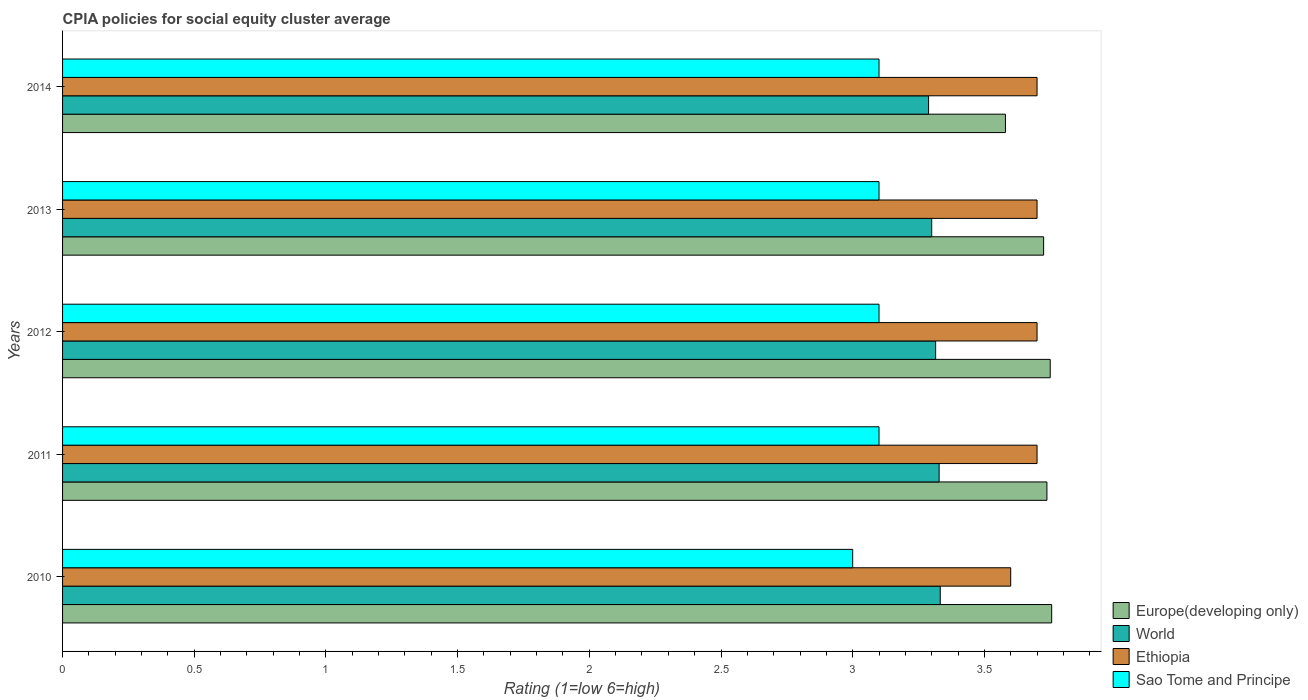How many different coloured bars are there?
Provide a succinct answer. 4. How many groups of bars are there?
Your answer should be compact. 5. Are the number of bars on each tick of the Y-axis equal?
Make the answer very short. Yes. How many bars are there on the 1st tick from the top?
Offer a very short reply. 4. What is the label of the 1st group of bars from the top?
Offer a terse response. 2014. Across all years, what is the maximum CPIA rating in Ethiopia?
Provide a short and direct response. 3.7. Across all years, what is the minimum CPIA rating in Europe(developing only)?
Your response must be concise. 3.58. In which year was the CPIA rating in Ethiopia maximum?
Offer a terse response. 2011. What is the total CPIA rating in Europe(developing only) in the graph?
Give a very brief answer. 18.55. What is the difference between the CPIA rating in Europe(developing only) in 2010 and that in 2012?
Give a very brief answer. 0.01. What is the difference between the CPIA rating in Sao Tome and Principe in 2010 and the CPIA rating in Europe(developing only) in 2011?
Ensure brevity in your answer.  -0.74. What is the average CPIA rating in World per year?
Your answer should be compact. 3.31. In the year 2014, what is the difference between the CPIA rating in Ethiopia and CPIA rating in World?
Provide a succinct answer. 0.41. What is the ratio of the CPIA rating in Europe(developing only) in 2012 to that in 2013?
Provide a short and direct response. 1.01. Is the difference between the CPIA rating in Ethiopia in 2013 and 2014 greater than the difference between the CPIA rating in World in 2013 and 2014?
Your answer should be very brief. No. What is the difference between the highest and the second highest CPIA rating in Europe(developing only)?
Offer a terse response. 0.01. What is the difference between the highest and the lowest CPIA rating in Ethiopia?
Offer a very short reply. 0.1. In how many years, is the CPIA rating in Europe(developing only) greater than the average CPIA rating in Europe(developing only) taken over all years?
Ensure brevity in your answer.  4. Is the sum of the CPIA rating in World in 2011 and 2014 greater than the maximum CPIA rating in Europe(developing only) across all years?
Make the answer very short. Yes. What does the 1st bar from the bottom in 2010 represents?
Offer a very short reply. Europe(developing only). Is it the case that in every year, the sum of the CPIA rating in World and CPIA rating in Ethiopia is greater than the CPIA rating in Sao Tome and Principe?
Make the answer very short. Yes. How many bars are there?
Keep it short and to the point. 20. Are all the bars in the graph horizontal?
Make the answer very short. Yes. How many years are there in the graph?
Give a very brief answer. 5. Where does the legend appear in the graph?
Offer a very short reply. Bottom right. How are the legend labels stacked?
Your response must be concise. Vertical. What is the title of the graph?
Make the answer very short. CPIA policies for social equity cluster average. Does "Yemen, Rep." appear as one of the legend labels in the graph?
Keep it short and to the point. No. What is the label or title of the X-axis?
Offer a very short reply. Rating (1=low 6=high). What is the Rating (1=low 6=high) of Europe(developing only) in 2010?
Ensure brevity in your answer.  3.76. What is the Rating (1=low 6=high) in World in 2010?
Your answer should be very brief. 3.33. What is the Rating (1=low 6=high) in Ethiopia in 2010?
Keep it short and to the point. 3.6. What is the Rating (1=low 6=high) of Europe(developing only) in 2011?
Offer a terse response. 3.74. What is the Rating (1=low 6=high) of World in 2011?
Offer a very short reply. 3.33. What is the Rating (1=low 6=high) of Europe(developing only) in 2012?
Your answer should be very brief. 3.75. What is the Rating (1=low 6=high) of World in 2012?
Provide a succinct answer. 3.31. What is the Rating (1=low 6=high) in Europe(developing only) in 2013?
Give a very brief answer. 3.73. What is the Rating (1=low 6=high) in World in 2013?
Provide a succinct answer. 3.3. What is the Rating (1=low 6=high) of Ethiopia in 2013?
Your response must be concise. 3.7. What is the Rating (1=low 6=high) in Sao Tome and Principe in 2013?
Provide a short and direct response. 3.1. What is the Rating (1=low 6=high) in Europe(developing only) in 2014?
Give a very brief answer. 3.58. What is the Rating (1=low 6=high) of World in 2014?
Offer a very short reply. 3.29. What is the Rating (1=low 6=high) of Ethiopia in 2014?
Offer a terse response. 3.7. What is the Rating (1=low 6=high) in Sao Tome and Principe in 2014?
Offer a terse response. 3.1. Across all years, what is the maximum Rating (1=low 6=high) in Europe(developing only)?
Your answer should be compact. 3.76. Across all years, what is the maximum Rating (1=low 6=high) in World?
Provide a short and direct response. 3.33. Across all years, what is the minimum Rating (1=low 6=high) of Europe(developing only)?
Give a very brief answer. 3.58. Across all years, what is the minimum Rating (1=low 6=high) of World?
Provide a short and direct response. 3.29. Across all years, what is the minimum Rating (1=low 6=high) of Ethiopia?
Make the answer very short. 3.6. What is the total Rating (1=low 6=high) of Europe(developing only) in the graph?
Offer a terse response. 18.55. What is the total Rating (1=low 6=high) in World in the graph?
Your answer should be very brief. 16.56. What is the total Rating (1=low 6=high) in Ethiopia in the graph?
Offer a terse response. 18.4. What is the difference between the Rating (1=low 6=high) of Europe(developing only) in 2010 and that in 2011?
Make the answer very short. 0.02. What is the difference between the Rating (1=low 6=high) of World in 2010 and that in 2011?
Give a very brief answer. 0. What is the difference between the Rating (1=low 6=high) of Ethiopia in 2010 and that in 2011?
Provide a short and direct response. -0.1. What is the difference between the Rating (1=low 6=high) in Europe(developing only) in 2010 and that in 2012?
Ensure brevity in your answer.  0.01. What is the difference between the Rating (1=low 6=high) in World in 2010 and that in 2012?
Make the answer very short. 0.02. What is the difference between the Rating (1=low 6=high) in Europe(developing only) in 2010 and that in 2013?
Offer a very short reply. 0.03. What is the difference between the Rating (1=low 6=high) in World in 2010 and that in 2013?
Your answer should be compact. 0.03. What is the difference between the Rating (1=low 6=high) in Ethiopia in 2010 and that in 2013?
Offer a very short reply. -0.1. What is the difference between the Rating (1=low 6=high) in Europe(developing only) in 2010 and that in 2014?
Provide a succinct answer. 0.18. What is the difference between the Rating (1=low 6=high) in World in 2010 and that in 2014?
Provide a short and direct response. 0.04. What is the difference between the Rating (1=low 6=high) in Ethiopia in 2010 and that in 2014?
Provide a succinct answer. -0.1. What is the difference between the Rating (1=low 6=high) in Sao Tome and Principe in 2010 and that in 2014?
Give a very brief answer. -0.1. What is the difference between the Rating (1=low 6=high) in Europe(developing only) in 2011 and that in 2012?
Make the answer very short. -0.01. What is the difference between the Rating (1=low 6=high) of World in 2011 and that in 2012?
Provide a short and direct response. 0.01. What is the difference between the Rating (1=low 6=high) of Ethiopia in 2011 and that in 2012?
Make the answer very short. 0. What is the difference between the Rating (1=low 6=high) of Europe(developing only) in 2011 and that in 2013?
Ensure brevity in your answer.  0.01. What is the difference between the Rating (1=low 6=high) of World in 2011 and that in 2013?
Offer a very short reply. 0.03. What is the difference between the Rating (1=low 6=high) in Europe(developing only) in 2011 and that in 2014?
Your answer should be very brief. 0.16. What is the difference between the Rating (1=low 6=high) in World in 2011 and that in 2014?
Provide a succinct answer. 0.04. What is the difference between the Rating (1=low 6=high) of Ethiopia in 2011 and that in 2014?
Give a very brief answer. 0. What is the difference between the Rating (1=low 6=high) in Europe(developing only) in 2012 and that in 2013?
Provide a succinct answer. 0.03. What is the difference between the Rating (1=low 6=high) of World in 2012 and that in 2013?
Offer a very short reply. 0.01. What is the difference between the Rating (1=low 6=high) of Europe(developing only) in 2012 and that in 2014?
Your response must be concise. 0.17. What is the difference between the Rating (1=low 6=high) in World in 2012 and that in 2014?
Offer a terse response. 0.03. What is the difference between the Rating (1=low 6=high) of Ethiopia in 2012 and that in 2014?
Your answer should be compact. 0. What is the difference between the Rating (1=low 6=high) of Sao Tome and Principe in 2012 and that in 2014?
Give a very brief answer. 0. What is the difference between the Rating (1=low 6=high) of Europe(developing only) in 2013 and that in 2014?
Keep it short and to the point. 0.14. What is the difference between the Rating (1=low 6=high) of World in 2013 and that in 2014?
Your answer should be compact. 0.01. What is the difference between the Rating (1=low 6=high) in Europe(developing only) in 2010 and the Rating (1=low 6=high) in World in 2011?
Ensure brevity in your answer.  0.43. What is the difference between the Rating (1=low 6=high) in Europe(developing only) in 2010 and the Rating (1=low 6=high) in Ethiopia in 2011?
Offer a terse response. 0.06. What is the difference between the Rating (1=low 6=high) in Europe(developing only) in 2010 and the Rating (1=low 6=high) in Sao Tome and Principe in 2011?
Provide a succinct answer. 0.66. What is the difference between the Rating (1=low 6=high) in World in 2010 and the Rating (1=low 6=high) in Ethiopia in 2011?
Make the answer very short. -0.37. What is the difference between the Rating (1=low 6=high) of World in 2010 and the Rating (1=low 6=high) of Sao Tome and Principe in 2011?
Provide a short and direct response. 0.23. What is the difference between the Rating (1=low 6=high) of Europe(developing only) in 2010 and the Rating (1=low 6=high) of World in 2012?
Give a very brief answer. 0.44. What is the difference between the Rating (1=low 6=high) in Europe(developing only) in 2010 and the Rating (1=low 6=high) in Ethiopia in 2012?
Provide a short and direct response. 0.06. What is the difference between the Rating (1=low 6=high) in Europe(developing only) in 2010 and the Rating (1=low 6=high) in Sao Tome and Principe in 2012?
Give a very brief answer. 0.66. What is the difference between the Rating (1=low 6=high) in World in 2010 and the Rating (1=low 6=high) in Ethiopia in 2012?
Ensure brevity in your answer.  -0.37. What is the difference between the Rating (1=low 6=high) in World in 2010 and the Rating (1=low 6=high) in Sao Tome and Principe in 2012?
Your answer should be compact. 0.23. What is the difference between the Rating (1=low 6=high) of Ethiopia in 2010 and the Rating (1=low 6=high) of Sao Tome and Principe in 2012?
Offer a terse response. 0.5. What is the difference between the Rating (1=low 6=high) of Europe(developing only) in 2010 and the Rating (1=low 6=high) of World in 2013?
Ensure brevity in your answer.  0.46. What is the difference between the Rating (1=low 6=high) of Europe(developing only) in 2010 and the Rating (1=low 6=high) of Ethiopia in 2013?
Make the answer very short. 0.06. What is the difference between the Rating (1=low 6=high) of Europe(developing only) in 2010 and the Rating (1=low 6=high) of Sao Tome and Principe in 2013?
Your answer should be compact. 0.66. What is the difference between the Rating (1=low 6=high) of World in 2010 and the Rating (1=low 6=high) of Ethiopia in 2013?
Your answer should be very brief. -0.37. What is the difference between the Rating (1=low 6=high) in World in 2010 and the Rating (1=low 6=high) in Sao Tome and Principe in 2013?
Make the answer very short. 0.23. What is the difference between the Rating (1=low 6=high) of Europe(developing only) in 2010 and the Rating (1=low 6=high) of World in 2014?
Give a very brief answer. 0.47. What is the difference between the Rating (1=low 6=high) in Europe(developing only) in 2010 and the Rating (1=low 6=high) in Ethiopia in 2014?
Give a very brief answer. 0.06. What is the difference between the Rating (1=low 6=high) of Europe(developing only) in 2010 and the Rating (1=low 6=high) of Sao Tome and Principe in 2014?
Your answer should be compact. 0.66. What is the difference between the Rating (1=low 6=high) in World in 2010 and the Rating (1=low 6=high) in Ethiopia in 2014?
Keep it short and to the point. -0.37. What is the difference between the Rating (1=low 6=high) of World in 2010 and the Rating (1=low 6=high) of Sao Tome and Principe in 2014?
Keep it short and to the point. 0.23. What is the difference between the Rating (1=low 6=high) in Ethiopia in 2010 and the Rating (1=low 6=high) in Sao Tome and Principe in 2014?
Your answer should be very brief. 0.5. What is the difference between the Rating (1=low 6=high) in Europe(developing only) in 2011 and the Rating (1=low 6=high) in World in 2012?
Offer a terse response. 0.42. What is the difference between the Rating (1=low 6=high) of Europe(developing only) in 2011 and the Rating (1=low 6=high) of Ethiopia in 2012?
Your response must be concise. 0.04. What is the difference between the Rating (1=low 6=high) of Europe(developing only) in 2011 and the Rating (1=low 6=high) of Sao Tome and Principe in 2012?
Offer a terse response. 0.64. What is the difference between the Rating (1=low 6=high) in World in 2011 and the Rating (1=low 6=high) in Ethiopia in 2012?
Provide a short and direct response. -0.37. What is the difference between the Rating (1=low 6=high) in World in 2011 and the Rating (1=low 6=high) in Sao Tome and Principe in 2012?
Provide a short and direct response. 0.23. What is the difference between the Rating (1=low 6=high) of Ethiopia in 2011 and the Rating (1=low 6=high) of Sao Tome and Principe in 2012?
Your answer should be very brief. 0.6. What is the difference between the Rating (1=low 6=high) of Europe(developing only) in 2011 and the Rating (1=low 6=high) of World in 2013?
Keep it short and to the point. 0.44. What is the difference between the Rating (1=low 6=high) of Europe(developing only) in 2011 and the Rating (1=low 6=high) of Ethiopia in 2013?
Offer a very short reply. 0.04. What is the difference between the Rating (1=low 6=high) of Europe(developing only) in 2011 and the Rating (1=low 6=high) of Sao Tome and Principe in 2013?
Keep it short and to the point. 0.64. What is the difference between the Rating (1=low 6=high) of World in 2011 and the Rating (1=low 6=high) of Ethiopia in 2013?
Ensure brevity in your answer.  -0.37. What is the difference between the Rating (1=low 6=high) of World in 2011 and the Rating (1=low 6=high) of Sao Tome and Principe in 2013?
Your answer should be very brief. 0.23. What is the difference between the Rating (1=low 6=high) of Ethiopia in 2011 and the Rating (1=low 6=high) of Sao Tome and Principe in 2013?
Offer a very short reply. 0.6. What is the difference between the Rating (1=low 6=high) of Europe(developing only) in 2011 and the Rating (1=low 6=high) of World in 2014?
Ensure brevity in your answer.  0.45. What is the difference between the Rating (1=low 6=high) in Europe(developing only) in 2011 and the Rating (1=low 6=high) in Ethiopia in 2014?
Your answer should be very brief. 0.04. What is the difference between the Rating (1=low 6=high) of Europe(developing only) in 2011 and the Rating (1=low 6=high) of Sao Tome and Principe in 2014?
Offer a terse response. 0.64. What is the difference between the Rating (1=low 6=high) of World in 2011 and the Rating (1=low 6=high) of Ethiopia in 2014?
Keep it short and to the point. -0.37. What is the difference between the Rating (1=low 6=high) in World in 2011 and the Rating (1=low 6=high) in Sao Tome and Principe in 2014?
Give a very brief answer. 0.23. What is the difference between the Rating (1=low 6=high) in Europe(developing only) in 2012 and the Rating (1=low 6=high) in World in 2013?
Provide a short and direct response. 0.45. What is the difference between the Rating (1=low 6=high) in Europe(developing only) in 2012 and the Rating (1=low 6=high) in Sao Tome and Principe in 2013?
Your answer should be very brief. 0.65. What is the difference between the Rating (1=low 6=high) of World in 2012 and the Rating (1=low 6=high) of Ethiopia in 2013?
Keep it short and to the point. -0.39. What is the difference between the Rating (1=low 6=high) of World in 2012 and the Rating (1=low 6=high) of Sao Tome and Principe in 2013?
Ensure brevity in your answer.  0.21. What is the difference between the Rating (1=low 6=high) of Europe(developing only) in 2012 and the Rating (1=low 6=high) of World in 2014?
Your answer should be very brief. 0.46. What is the difference between the Rating (1=low 6=high) in Europe(developing only) in 2012 and the Rating (1=low 6=high) in Sao Tome and Principe in 2014?
Your answer should be very brief. 0.65. What is the difference between the Rating (1=low 6=high) of World in 2012 and the Rating (1=low 6=high) of Ethiopia in 2014?
Your answer should be compact. -0.39. What is the difference between the Rating (1=low 6=high) of World in 2012 and the Rating (1=low 6=high) of Sao Tome and Principe in 2014?
Your response must be concise. 0.21. What is the difference between the Rating (1=low 6=high) of Europe(developing only) in 2013 and the Rating (1=low 6=high) of World in 2014?
Keep it short and to the point. 0.44. What is the difference between the Rating (1=low 6=high) of Europe(developing only) in 2013 and the Rating (1=low 6=high) of Ethiopia in 2014?
Keep it short and to the point. 0.03. What is the difference between the Rating (1=low 6=high) of Ethiopia in 2013 and the Rating (1=low 6=high) of Sao Tome and Principe in 2014?
Your answer should be very brief. 0.6. What is the average Rating (1=low 6=high) in Europe(developing only) per year?
Provide a short and direct response. 3.71. What is the average Rating (1=low 6=high) of World per year?
Provide a succinct answer. 3.31. What is the average Rating (1=low 6=high) in Ethiopia per year?
Your answer should be very brief. 3.68. What is the average Rating (1=low 6=high) of Sao Tome and Principe per year?
Your answer should be compact. 3.08. In the year 2010, what is the difference between the Rating (1=low 6=high) in Europe(developing only) and Rating (1=low 6=high) in World?
Your response must be concise. 0.42. In the year 2010, what is the difference between the Rating (1=low 6=high) of Europe(developing only) and Rating (1=low 6=high) of Ethiopia?
Make the answer very short. 0.16. In the year 2010, what is the difference between the Rating (1=low 6=high) of Europe(developing only) and Rating (1=low 6=high) of Sao Tome and Principe?
Ensure brevity in your answer.  0.76. In the year 2010, what is the difference between the Rating (1=low 6=high) in World and Rating (1=low 6=high) in Ethiopia?
Offer a terse response. -0.27. In the year 2010, what is the difference between the Rating (1=low 6=high) of World and Rating (1=low 6=high) of Sao Tome and Principe?
Your answer should be very brief. 0.33. In the year 2011, what is the difference between the Rating (1=low 6=high) of Europe(developing only) and Rating (1=low 6=high) of World?
Your answer should be compact. 0.41. In the year 2011, what is the difference between the Rating (1=low 6=high) in Europe(developing only) and Rating (1=low 6=high) in Ethiopia?
Keep it short and to the point. 0.04. In the year 2011, what is the difference between the Rating (1=low 6=high) in Europe(developing only) and Rating (1=low 6=high) in Sao Tome and Principe?
Your answer should be very brief. 0.64. In the year 2011, what is the difference between the Rating (1=low 6=high) of World and Rating (1=low 6=high) of Ethiopia?
Provide a short and direct response. -0.37. In the year 2011, what is the difference between the Rating (1=low 6=high) in World and Rating (1=low 6=high) in Sao Tome and Principe?
Offer a terse response. 0.23. In the year 2011, what is the difference between the Rating (1=low 6=high) of Ethiopia and Rating (1=low 6=high) of Sao Tome and Principe?
Keep it short and to the point. 0.6. In the year 2012, what is the difference between the Rating (1=low 6=high) in Europe(developing only) and Rating (1=low 6=high) in World?
Provide a short and direct response. 0.43. In the year 2012, what is the difference between the Rating (1=low 6=high) in Europe(developing only) and Rating (1=low 6=high) in Ethiopia?
Your answer should be very brief. 0.05. In the year 2012, what is the difference between the Rating (1=low 6=high) in Europe(developing only) and Rating (1=low 6=high) in Sao Tome and Principe?
Your answer should be very brief. 0.65. In the year 2012, what is the difference between the Rating (1=low 6=high) of World and Rating (1=low 6=high) of Ethiopia?
Offer a terse response. -0.39. In the year 2012, what is the difference between the Rating (1=low 6=high) in World and Rating (1=low 6=high) in Sao Tome and Principe?
Keep it short and to the point. 0.21. In the year 2012, what is the difference between the Rating (1=low 6=high) of Ethiopia and Rating (1=low 6=high) of Sao Tome and Principe?
Keep it short and to the point. 0.6. In the year 2013, what is the difference between the Rating (1=low 6=high) in Europe(developing only) and Rating (1=low 6=high) in World?
Provide a short and direct response. 0.42. In the year 2013, what is the difference between the Rating (1=low 6=high) of Europe(developing only) and Rating (1=low 6=high) of Ethiopia?
Your response must be concise. 0.03. In the year 2013, what is the difference between the Rating (1=low 6=high) in World and Rating (1=low 6=high) in Sao Tome and Principe?
Provide a succinct answer. 0.2. In the year 2013, what is the difference between the Rating (1=low 6=high) of Ethiopia and Rating (1=low 6=high) of Sao Tome and Principe?
Ensure brevity in your answer.  0.6. In the year 2014, what is the difference between the Rating (1=low 6=high) in Europe(developing only) and Rating (1=low 6=high) in World?
Your response must be concise. 0.29. In the year 2014, what is the difference between the Rating (1=low 6=high) of Europe(developing only) and Rating (1=low 6=high) of Ethiopia?
Keep it short and to the point. -0.12. In the year 2014, what is the difference between the Rating (1=low 6=high) in Europe(developing only) and Rating (1=low 6=high) in Sao Tome and Principe?
Provide a succinct answer. 0.48. In the year 2014, what is the difference between the Rating (1=low 6=high) of World and Rating (1=low 6=high) of Ethiopia?
Keep it short and to the point. -0.41. In the year 2014, what is the difference between the Rating (1=low 6=high) of World and Rating (1=low 6=high) of Sao Tome and Principe?
Offer a terse response. 0.19. In the year 2014, what is the difference between the Rating (1=low 6=high) in Ethiopia and Rating (1=low 6=high) in Sao Tome and Principe?
Keep it short and to the point. 0.6. What is the ratio of the Rating (1=low 6=high) of Sao Tome and Principe in 2010 to that in 2011?
Ensure brevity in your answer.  0.97. What is the ratio of the Rating (1=low 6=high) in World in 2010 to that in 2012?
Offer a terse response. 1.01. What is the ratio of the Rating (1=low 6=high) in Europe(developing only) in 2010 to that in 2013?
Ensure brevity in your answer.  1.01. What is the ratio of the Rating (1=low 6=high) in World in 2010 to that in 2013?
Offer a very short reply. 1.01. What is the ratio of the Rating (1=low 6=high) in Sao Tome and Principe in 2010 to that in 2013?
Your response must be concise. 0.97. What is the ratio of the Rating (1=low 6=high) of Europe(developing only) in 2010 to that in 2014?
Offer a very short reply. 1.05. What is the ratio of the Rating (1=low 6=high) of World in 2010 to that in 2014?
Your answer should be compact. 1.01. What is the ratio of the Rating (1=low 6=high) in Europe(developing only) in 2011 to that in 2012?
Keep it short and to the point. 1. What is the ratio of the Rating (1=low 6=high) of Ethiopia in 2011 to that in 2012?
Offer a very short reply. 1. What is the ratio of the Rating (1=low 6=high) in Sao Tome and Principe in 2011 to that in 2012?
Give a very brief answer. 1. What is the ratio of the Rating (1=low 6=high) of World in 2011 to that in 2013?
Give a very brief answer. 1.01. What is the ratio of the Rating (1=low 6=high) in Sao Tome and Principe in 2011 to that in 2013?
Your response must be concise. 1. What is the ratio of the Rating (1=low 6=high) in Europe(developing only) in 2011 to that in 2014?
Provide a short and direct response. 1.04. What is the ratio of the Rating (1=low 6=high) in World in 2011 to that in 2014?
Offer a very short reply. 1.01. What is the ratio of the Rating (1=low 6=high) of Ethiopia in 2012 to that in 2013?
Give a very brief answer. 1. What is the ratio of the Rating (1=low 6=high) of Europe(developing only) in 2012 to that in 2014?
Your answer should be very brief. 1.05. What is the ratio of the Rating (1=low 6=high) in World in 2012 to that in 2014?
Provide a short and direct response. 1.01. What is the ratio of the Rating (1=low 6=high) in Sao Tome and Principe in 2012 to that in 2014?
Provide a short and direct response. 1. What is the ratio of the Rating (1=low 6=high) in Europe(developing only) in 2013 to that in 2014?
Provide a succinct answer. 1.04. What is the ratio of the Rating (1=low 6=high) of Ethiopia in 2013 to that in 2014?
Provide a short and direct response. 1. What is the ratio of the Rating (1=low 6=high) of Sao Tome and Principe in 2013 to that in 2014?
Your answer should be compact. 1. What is the difference between the highest and the second highest Rating (1=low 6=high) of Europe(developing only)?
Make the answer very short. 0.01. What is the difference between the highest and the second highest Rating (1=low 6=high) of World?
Offer a terse response. 0. What is the difference between the highest and the second highest Rating (1=low 6=high) in Ethiopia?
Provide a short and direct response. 0. What is the difference between the highest and the lowest Rating (1=low 6=high) of Europe(developing only)?
Make the answer very short. 0.18. What is the difference between the highest and the lowest Rating (1=low 6=high) in World?
Make the answer very short. 0.04. What is the difference between the highest and the lowest Rating (1=low 6=high) in Sao Tome and Principe?
Offer a terse response. 0.1. 